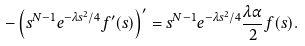Convert formula to latex. <formula><loc_0><loc_0><loc_500><loc_500>- \left ( s ^ { N - 1 } e ^ { - \lambda s ^ { 2 } / 4 } f ^ { \prime } ( s ) \right ) ^ { \prime } = s ^ { N - 1 } e ^ { - \lambda s ^ { 2 } / 4 } \frac { \lambda \alpha } { 2 } f ( s ) .</formula> 